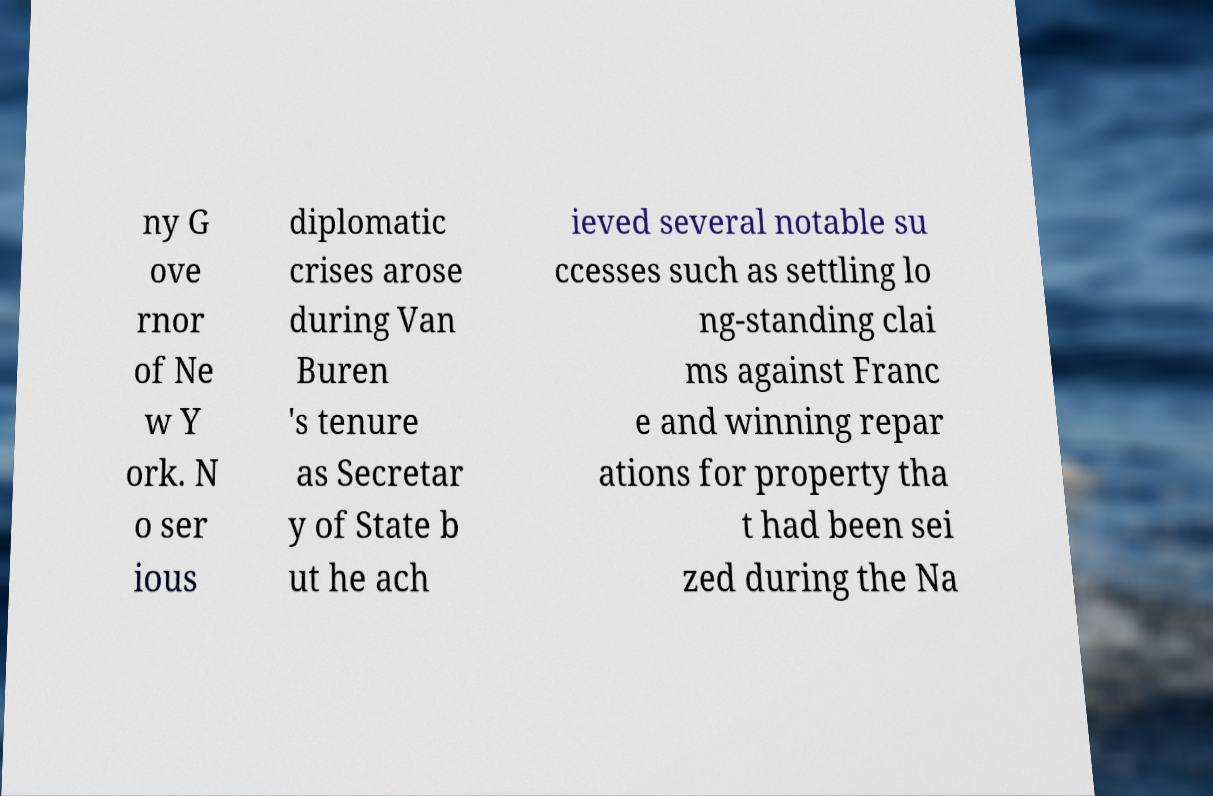I need the written content from this picture converted into text. Can you do that? ny G ove rnor of Ne w Y ork. N o ser ious diplomatic crises arose during Van Buren 's tenure as Secretar y of State b ut he ach ieved several notable su ccesses such as settling lo ng-standing clai ms against Franc e and winning repar ations for property tha t had been sei zed during the Na 